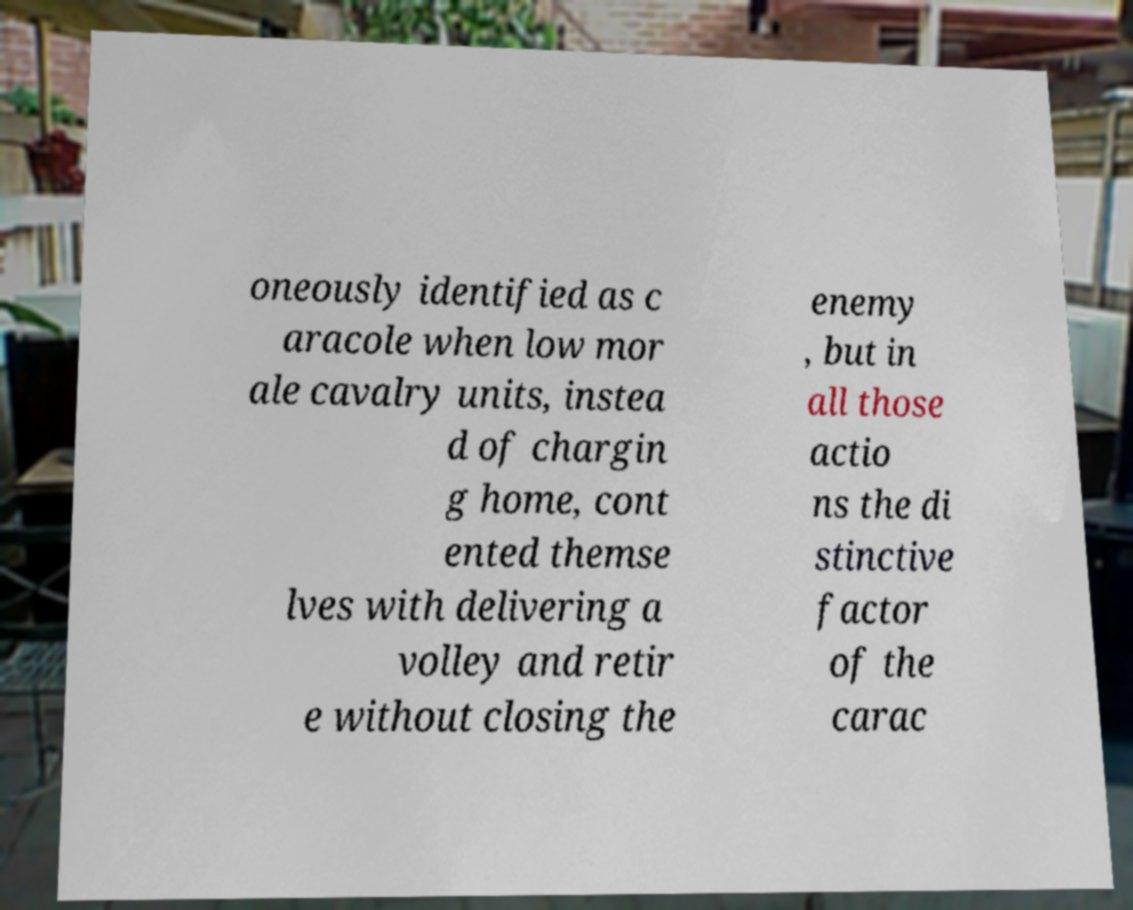Please identify and transcribe the text found in this image. oneously identified as c aracole when low mor ale cavalry units, instea d of chargin g home, cont ented themse lves with delivering a volley and retir e without closing the enemy , but in all those actio ns the di stinctive factor of the carac 